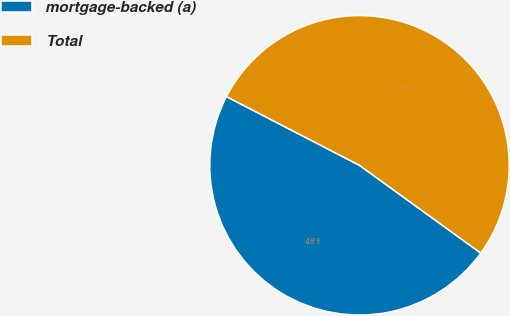Convert chart to OTSL. <chart><loc_0><loc_0><loc_500><loc_500><pie_chart><fcel>mortgage-backed (a)<fcel>Total<nl><fcel>47.62%<fcel>52.38%<nl></chart> 